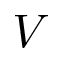<formula> <loc_0><loc_0><loc_500><loc_500>V</formula> 